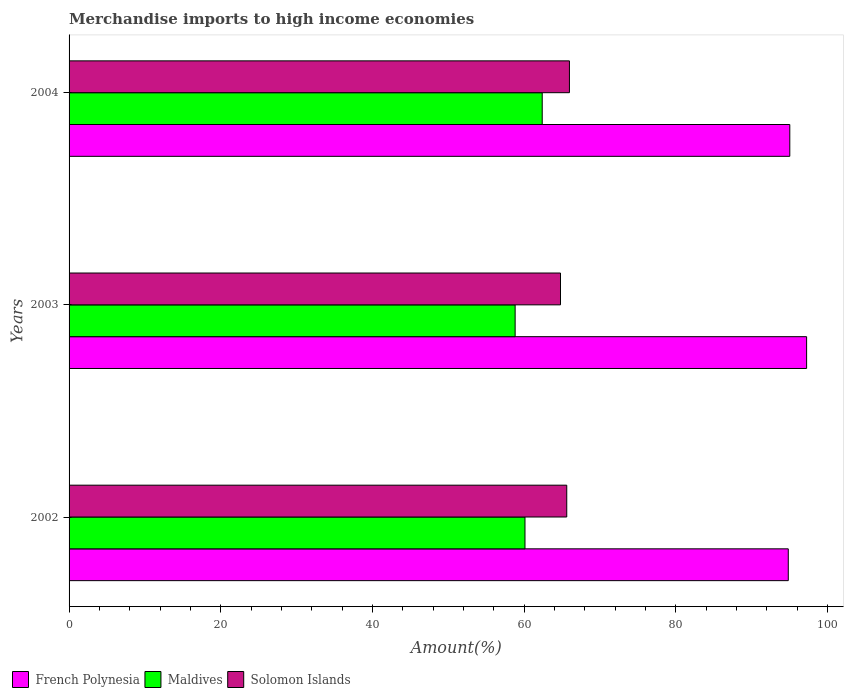How many different coloured bars are there?
Keep it short and to the point. 3. How many groups of bars are there?
Make the answer very short. 3. Are the number of bars on each tick of the Y-axis equal?
Make the answer very short. Yes. How many bars are there on the 1st tick from the bottom?
Provide a short and direct response. 3. What is the label of the 3rd group of bars from the top?
Ensure brevity in your answer.  2002. What is the percentage of amount earned from merchandise imports in Maldives in 2002?
Your response must be concise. 60.12. Across all years, what is the maximum percentage of amount earned from merchandise imports in Maldives?
Give a very brief answer. 62.39. Across all years, what is the minimum percentage of amount earned from merchandise imports in Maldives?
Your answer should be very brief. 58.82. What is the total percentage of amount earned from merchandise imports in Maldives in the graph?
Your answer should be compact. 181.32. What is the difference between the percentage of amount earned from merchandise imports in Solomon Islands in 2002 and that in 2003?
Offer a very short reply. 0.82. What is the difference between the percentage of amount earned from merchandise imports in Maldives in 2003 and the percentage of amount earned from merchandise imports in French Polynesia in 2002?
Provide a short and direct response. -36.02. What is the average percentage of amount earned from merchandise imports in Solomon Islands per year?
Make the answer very short. 65.47. In the year 2002, what is the difference between the percentage of amount earned from merchandise imports in Solomon Islands and percentage of amount earned from merchandise imports in French Polynesia?
Offer a very short reply. -29.21. What is the ratio of the percentage of amount earned from merchandise imports in Maldives in 2002 to that in 2003?
Ensure brevity in your answer.  1.02. Is the difference between the percentage of amount earned from merchandise imports in Solomon Islands in 2002 and 2004 greater than the difference between the percentage of amount earned from merchandise imports in French Polynesia in 2002 and 2004?
Give a very brief answer. No. What is the difference between the highest and the second highest percentage of amount earned from merchandise imports in French Polynesia?
Keep it short and to the point. 2.22. What is the difference between the highest and the lowest percentage of amount earned from merchandise imports in French Polynesia?
Ensure brevity in your answer.  2.42. Is the sum of the percentage of amount earned from merchandise imports in Solomon Islands in 2002 and 2003 greater than the maximum percentage of amount earned from merchandise imports in French Polynesia across all years?
Ensure brevity in your answer.  Yes. What does the 2nd bar from the top in 2003 represents?
Give a very brief answer. Maldives. What does the 2nd bar from the bottom in 2003 represents?
Give a very brief answer. Maldives. Are the values on the major ticks of X-axis written in scientific E-notation?
Offer a very short reply. No. Does the graph contain any zero values?
Your answer should be compact. No. Where does the legend appear in the graph?
Make the answer very short. Bottom left. How are the legend labels stacked?
Your answer should be compact. Horizontal. What is the title of the graph?
Provide a short and direct response. Merchandise imports to high income economies. What is the label or title of the X-axis?
Make the answer very short. Amount(%). What is the label or title of the Y-axis?
Your answer should be compact. Years. What is the Amount(%) in French Polynesia in 2002?
Offer a very short reply. 94.84. What is the Amount(%) of Maldives in 2002?
Your answer should be compact. 60.12. What is the Amount(%) of Solomon Islands in 2002?
Your response must be concise. 65.62. What is the Amount(%) of French Polynesia in 2003?
Keep it short and to the point. 97.25. What is the Amount(%) of Maldives in 2003?
Offer a very short reply. 58.82. What is the Amount(%) in Solomon Islands in 2003?
Make the answer very short. 64.8. What is the Amount(%) in French Polynesia in 2004?
Provide a succinct answer. 95.03. What is the Amount(%) of Maldives in 2004?
Offer a very short reply. 62.39. What is the Amount(%) in Solomon Islands in 2004?
Give a very brief answer. 65.98. Across all years, what is the maximum Amount(%) of French Polynesia?
Offer a terse response. 97.25. Across all years, what is the maximum Amount(%) of Maldives?
Your response must be concise. 62.39. Across all years, what is the maximum Amount(%) of Solomon Islands?
Your answer should be compact. 65.98. Across all years, what is the minimum Amount(%) of French Polynesia?
Your answer should be very brief. 94.84. Across all years, what is the minimum Amount(%) of Maldives?
Your response must be concise. 58.82. Across all years, what is the minimum Amount(%) in Solomon Islands?
Make the answer very short. 64.8. What is the total Amount(%) of French Polynesia in the graph?
Your response must be concise. 287.12. What is the total Amount(%) in Maldives in the graph?
Make the answer very short. 181.32. What is the total Amount(%) in Solomon Islands in the graph?
Keep it short and to the point. 196.4. What is the difference between the Amount(%) of French Polynesia in 2002 and that in 2003?
Offer a very short reply. -2.42. What is the difference between the Amount(%) in Maldives in 2002 and that in 2003?
Offer a very short reply. 1.3. What is the difference between the Amount(%) in Solomon Islands in 2002 and that in 2003?
Your answer should be compact. 0.82. What is the difference between the Amount(%) in French Polynesia in 2002 and that in 2004?
Ensure brevity in your answer.  -0.2. What is the difference between the Amount(%) in Maldives in 2002 and that in 2004?
Offer a terse response. -2.27. What is the difference between the Amount(%) of Solomon Islands in 2002 and that in 2004?
Provide a succinct answer. -0.35. What is the difference between the Amount(%) in French Polynesia in 2003 and that in 2004?
Give a very brief answer. 2.22. What is the difference between the Amount(%) in Maldives in 2003 and that in 2004?
Keep it short and to the point. -3.57. What is the difference between the Amount(%) in Solomon Islands in 2003 and that in 2004?
Make the answer very short. -1.18. What is the difference between the Amount(%) in French Polynesia in 2002 and the Amount(%) in Maldives in 2003?
Your response must be concise. 36.02. What is the difference between the Amount(%) in French Polynesia in 2002 and the Amount(%) in Solomon Islands in 2003?
Your answer should be very brief. 30.04. What is the difference between the Amount(%) of Maldives in 2002 and the Amount(%) of Solomon Islands in 2003?
Your answer should be compact. -4.68. What is the difference between the Amount(%) of French Polynesia in 2002 and the Amount(%) of Maldives in 2004?
Offer a terse response. 32.45. What is the difference between the Amount(%) of French Polynesia in 2002 and the Amount(%) of Solomon Islands in 2004?
Make the answer very short. 28.86. What is the difference between the Amount(%) in Maldives in 2002 and the Amount(%) in Solomon Islands in 2004?
Keep it short and to the point. -5.86. What is the difference between the Amount(%) of French Polynesia in 2003 and the Amount(%) of Maldives in 2004?
Give a very brief answer. 34.86. What is the difference between the Amount(%) of French Polynesia in 2003 and the Amount(%) of Solomon Islands in 2004?
Make the answer very short. 31.27. What is the difference between the Amount(%) of Maldives in 2003 and the Amount(%) of Solomon Islands in 2004?
Offer a terse response. -7.16. What is the average Amount(%) of French Polynesia per year?
Keep it short and to the point. 95.71. What is the average Amount(%) in Maldives per year?
Provide a succinct answer. 60.44. What is the average Amount(%) in Solomon Islands per year?
Your answer should be very brief. 65.47. In the year 2002, what is the difference between the Amount(%) in French Polynesia and Amount(%) in Maldives?
Give a very brief answer. 34.72. In the year 2002, what is the difference between the Amount(%) of French Polynesia and Amount(%) of Solomon Islands?
Your answer should be very brief. 29.21. In the year 2002, what is the difference between the Amount(%) in Maldives and Amount(%) in Solomon Islands?
Provide a short and direct response. -5.51. In the year 2003, what is the difference between the Amount(%) of French Polynesia and Amount(%) of Maldives?
Offer a very short reply. 38.43. In the year 2003, what is the difference between the Amount(%) in French Polynesia and Amount(%) in Solomon Islands?
Your response must be concise. 32.45. In the year 2003, what is the difference between the Amount(%) of Maldives and Amount(%) of Solomon Islands?
Give a very brief answer. -5.98. In the year 2004, what is the difference between the Amount(%) of French Polynesia and Amount(%) of Maldives?
Offer a terse response. 32.65. In the year 2004, what is the difference between the Amount(%) of French Polynesia and Amount(%) of Solomon Islands?
Ensure brevity in your answer.  29.06. In the year 2004, what is the difference between the Amount(%) in Maldives and Amount(%) in Solomon Islands?
Provide a short and direct response. -3.59. What is the ratio of the Amount(%) in French Polynesia in 2002 to that in 2003?
Keep it short and to the point. 0.98. What is the ratio of the Amount(%) in Maldives in 2002 to that in 2003?
Offer a very short reply. 1.02. What is the ratio of the Amount(%) of Solomon Islands in 2002 to that in 2003?
Your answer should be compact. 1.01. What is the ratio of the Amount(%) in Maldives in 2002 to that in 2004?
Your answer should be very brief. 0.96. What is the ratio of the Amount(%) of Solomon Islands in 2002 to that in 2004?
Your answer should be compact. 0.99. What is the ratio of the Amount(%) in French Polynesia in 2003 to that in 2004?
Give a very brief answer. 1.02. What is the ratio of the Amount(%) in Maldives in 2003 to that in 2004?
Ensure brevity in your answer.  0.94. What is the ratio of the Amount(%) of Solomon Islands in 2003 to that in 2004?
Provide a succinct answer. 0.98. What is the difference between the highest and the second highest Amount(%) in French Polynesia?
Your answer should be compact. 2.22. What is the difference between the highest and the second highest Amount(%) in Maldives?
Offer a very short reply. 2.27. What is the difference between the highest and the second highest Amount(%) in Solomon Islands?
Provide a short and direct response. 0.35. What is the difference between the highest and the lowest Amount(%) of French Polynesia?
Your answer should be very brief. 2.42. What is the difference between the highest and the lowest Amount(%) in Maldives?
Provide a succinct answer. 3.57. What is the difference between the highest and the lowest Amount(%) of Solomon Islands?
Your answer should be very brief. 1.18. 